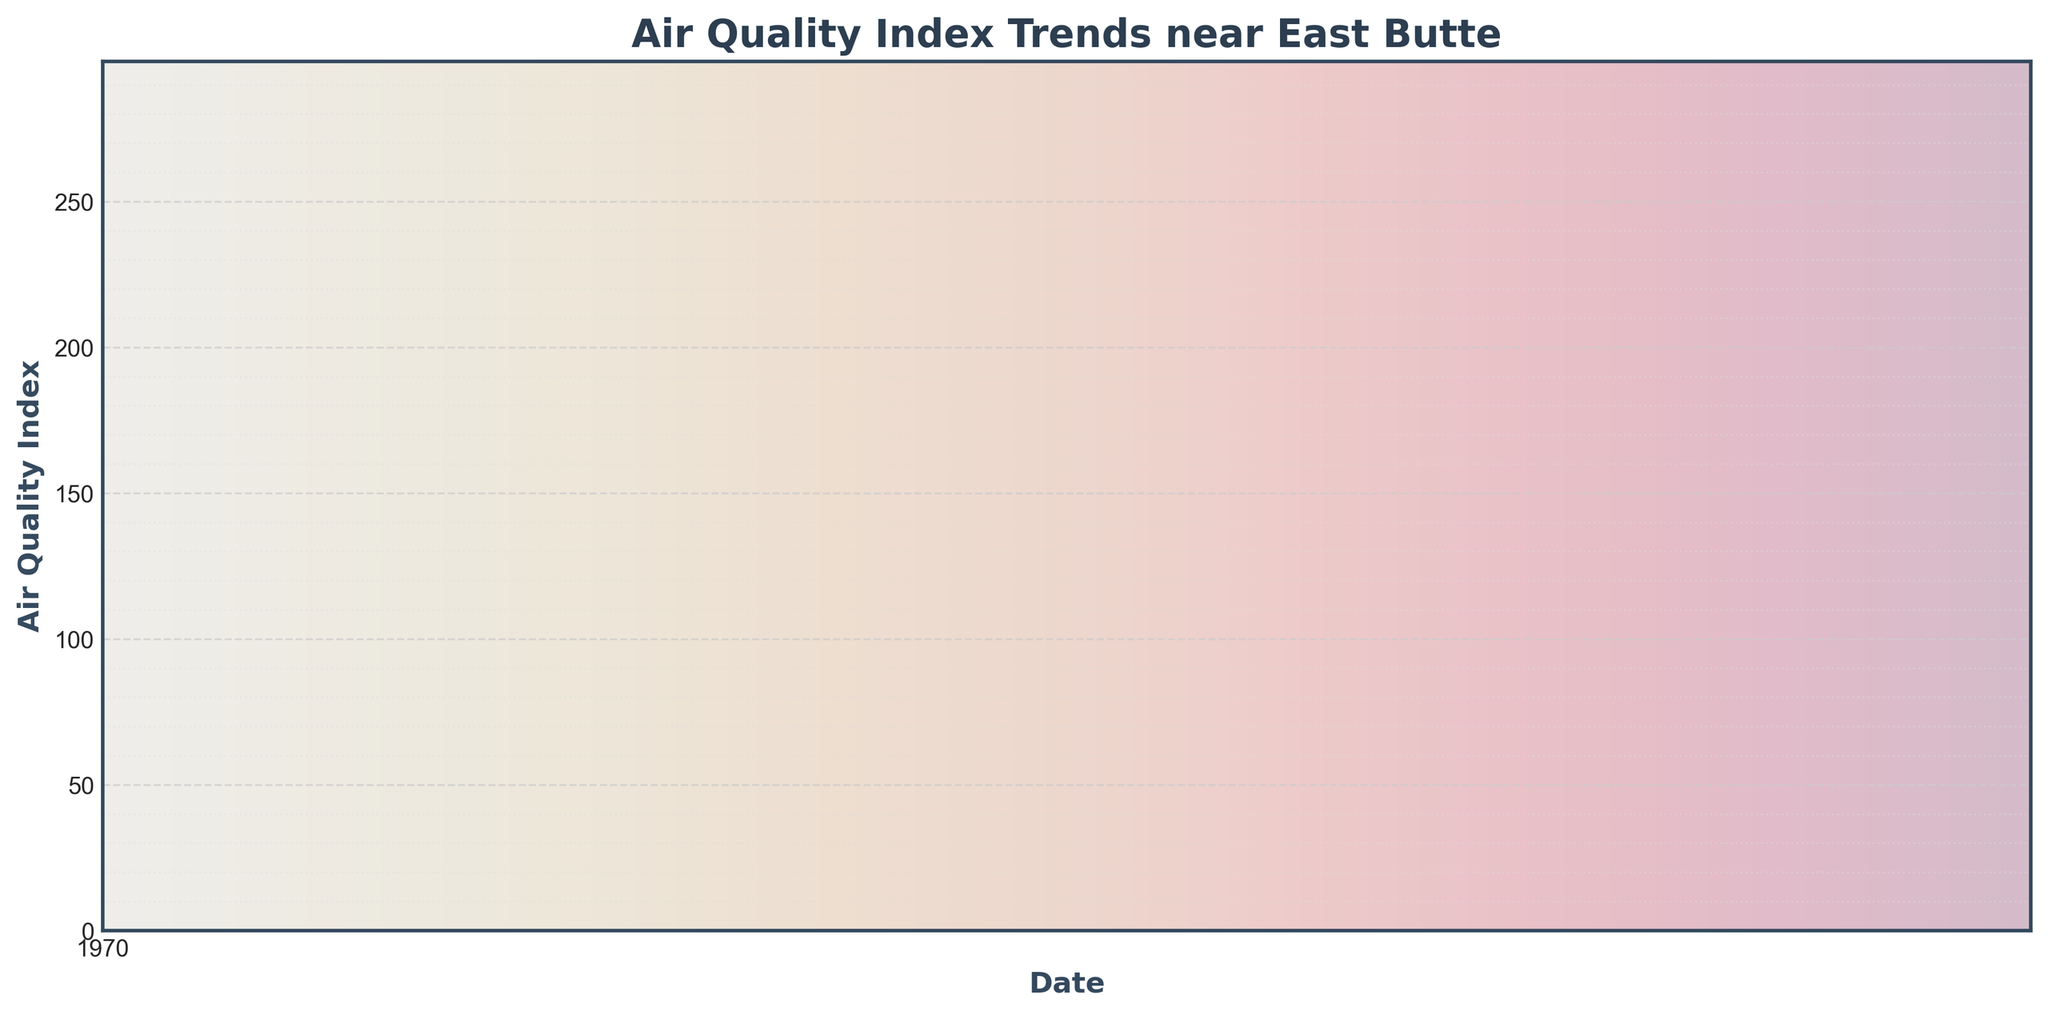What is the maximum air quality index value recorded in the past 3 years? Locate the peak point on the line chart where a red annotated text is marked "Max:". The value corresponds to 271.
Answer: 271 How has the air quality index changed from May to August 2020? Examine the line segment corresponding to the months May to August 2020 on the x-axis. The air quality index starts at 42 in May and increases steadily, reaching around 87 by the end of August.
Answer: Increased from 42 to 87 What is the overall trend in the air quality index over the 3 years? Look at the overall shape of the line chart from the beginning to the end. The line shows a clear upward trend, indicating a steady increase in the air quality index.
Answer: Upward What is the difference between the air quality index values at the beginning and the end of the period? Identify the values at the very beginning and the very end of the chart, which are 42 and 271, respectively. Subtract the initial value from the final value (271 - 42).
Answer: 229 Compare the air quality index in January 2021 and January 2022. Which one is higher? Find the points corresponding to January 2021 and January 2022 on the x-axis and compare the values. January 2021 has an index of about 28-37, while January 2022's index is around 133-141. January 2022 is higher.
Answer: January 2022 What visual elements are used to mark the highest air quality index value on the chart? Notice the annotation marked in red color with an arrow pointing to the peak value of the air quality index. The maximum value is also highlighted textually.
Answer: Red annotation and arrow Does the air quality index tend to drop at any time of the year? If so, when? Look for any recurring downward trend in the line chart throughout the 3-year period. A noticeable drop is observed around every November to early January.
Answer: November to January By how much did the air quality index increase from January 2020 to January 2023? Find the values for January 2020 and January 2023, which are 28 and 245 respectively, and calculate the difference (245 - 28).
Answer: 217 What is the average air quality index in July 2021? Identify the data points for July 2021: (81, 83, 85, 87). Sum these values (81 + 83 + 85 + 87) and divide by the number of data points (4). The average is (81 + 83 + 85 + 87) / 4.
Answer: 84 Has there been any period of stability (i.e., relatively constant values) in the air quality index? If yes, when did it occur? Examine the line chart for any flat or nearly flat segments. One such period is from October 2020 to March 2021, where the values range narrowly between 31 to 57.
Answer: October 2020 to March 2021 